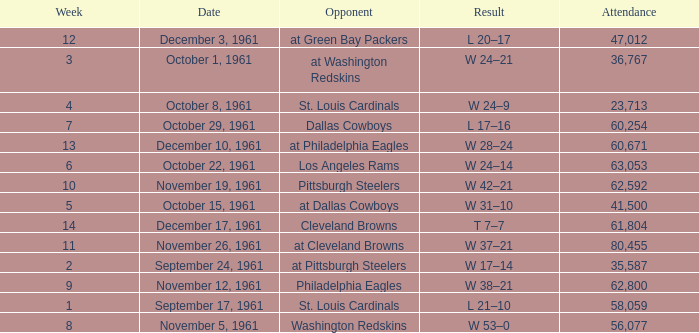Which Attendance has a Date of november 19, 1961? 62592.0. 